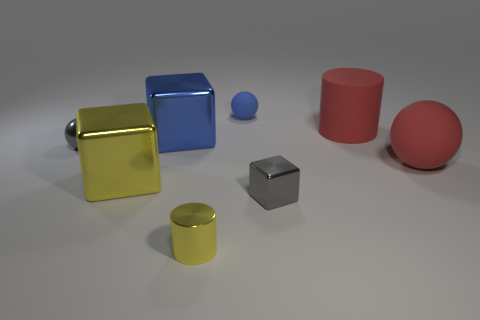Subtract all large metallic blocks. How many blocks are left? 1 Subtract all purple cubes. Subtract all yellow spheres. How many cubes are left? 3 Add 2 large blue cubes. How many objects exist? 10 Subtract all cubes. How many objects are left? 5 Subtract 0 yellow balls. How many objects are left? 8 Subtract all balls. Subtract all large cyan metal cylinders. How many objects are left? 5 Add 8 shiny cylinders. How many shiny cylinders are left? 9 Add 1 small purple shiny cylinders. How many small purple shiny cylinders exist? 1 